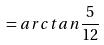<formula> <loc_0><loc_0><loc_500><loc_500>= a r c t a n \frac { 5 } { 1 2 }</formula> 